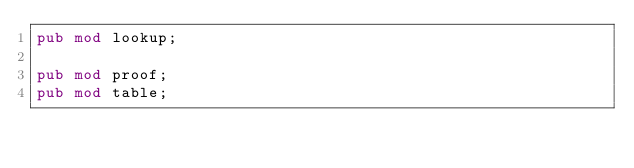<code> <loc_0><loc_0><loc_500><loc_500><_Rust_>pub mod lookup;

pub mod proof;
pub mod table;
</code> 